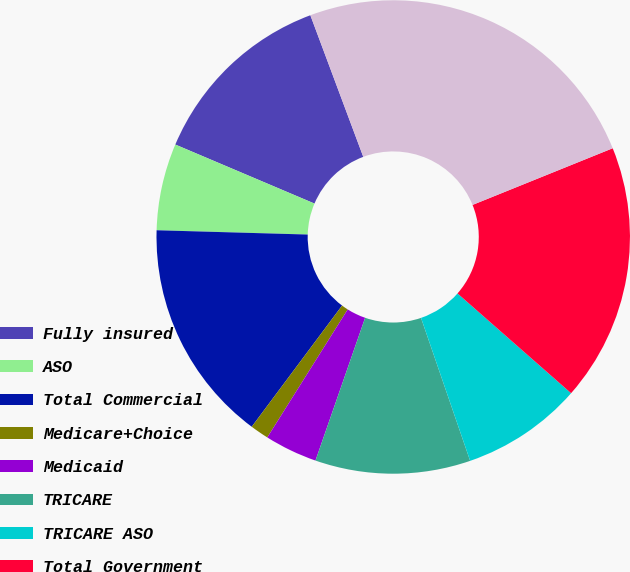Convert chart. <chart><loc_0><loc_0><loc_500><loc_500><pie_chart><fcel>Fully insured<fcel>ASO<fcel>Total Commercial<fcel>Medicare+Choice<fcel>Medicaid<fcel>TRICARE<fcel>TRICARE ASO<fcel>Total Government<fcel>Total medical membership<nl><fcel>12.92%<fcel>5.93%<fcel>15.25%<fcel>1.27%<fcel>3.6%<fcel>10.59%<fcel>8.26%<fcel>17.58%<fcel>24.57%<nl></chart> 